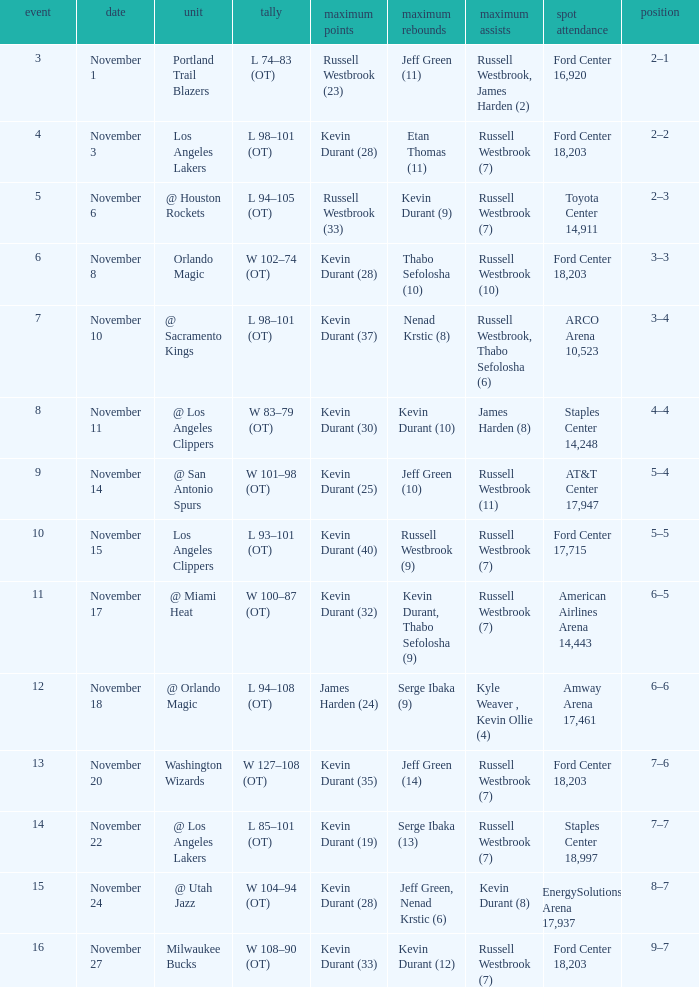Where was the game in which Kevin Durant (25) did the most high points played? AT&T Center 17,947. 